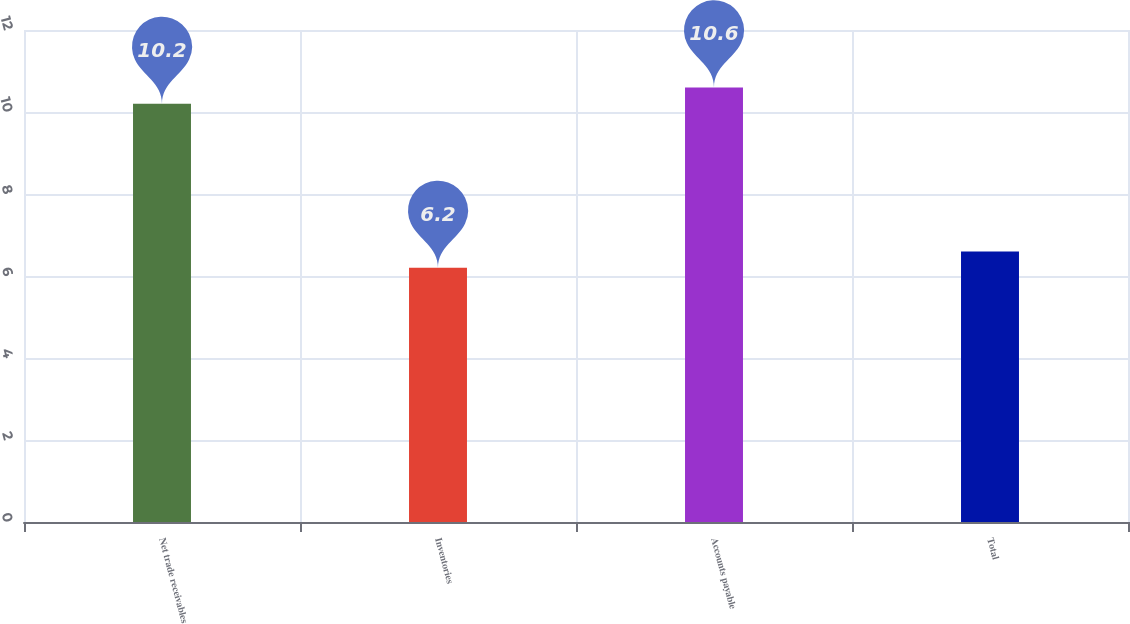Convert chart to OTSL. <chart><loc_0><loc_0><loc_500><loc_500><bar_chart><fcel>Net trade receivables<fcel>Inventories<fcel>Accounts payable<fcel>Total<nl><fcel>10.2<fcel>6.2<fcel>10.6<fcel>6.6<nl></chart> 